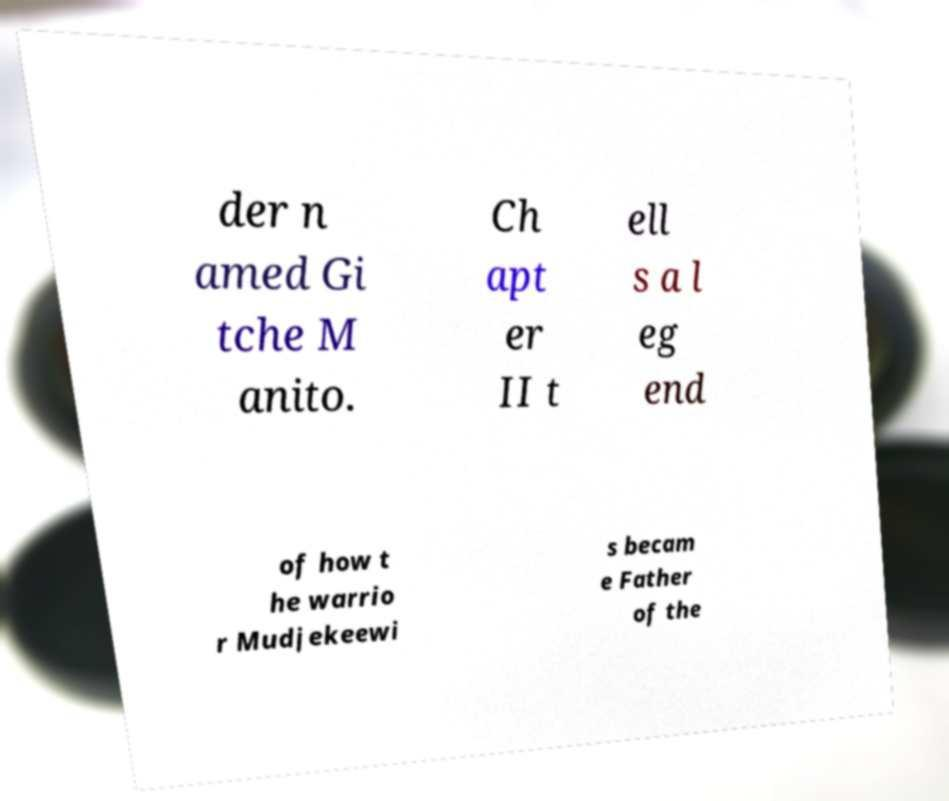For documentation purposes, I need the text within this image transcribed. Could you provide that? der n amed Gi tche M anito. Ch apt er II t ell s a l eg end of how t he warrio r Mudjekeewi s becam e Father of the 